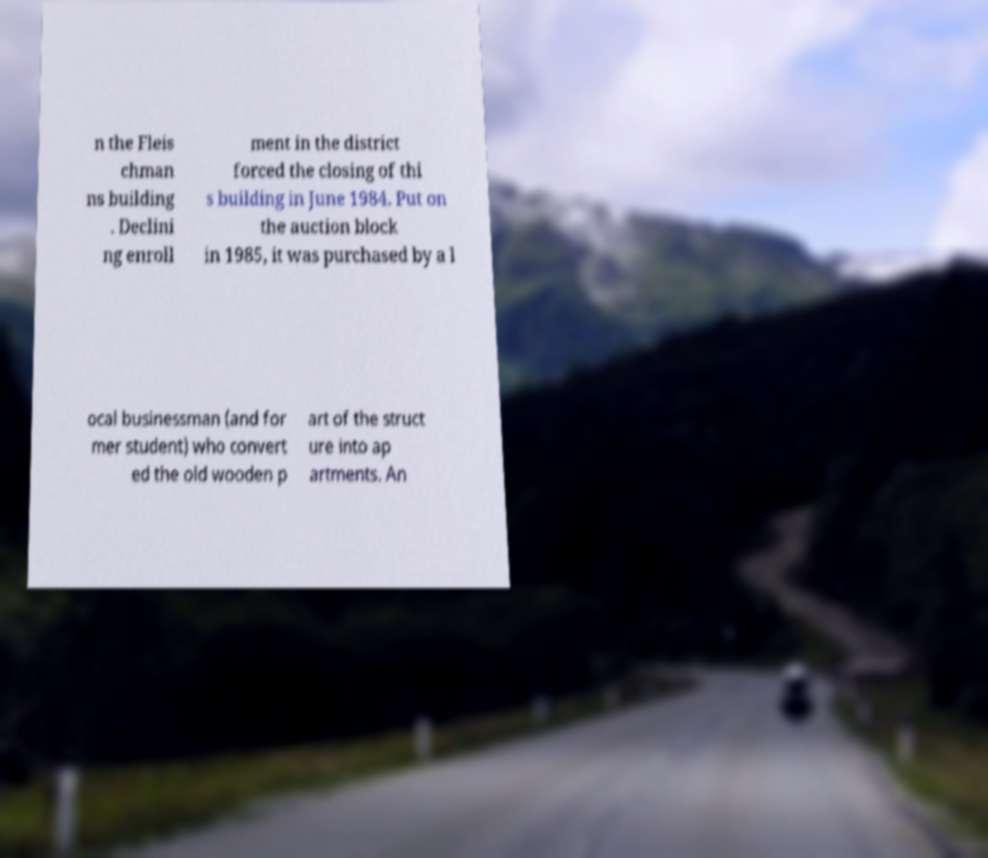What messages or text are displayed in this image? I need them in a readable, typed format. n the Fleis chman ns building . Declini ng enroll ment in the district forced the closing of thi s building in June 1984. Put on the auction block in 1985, it was purchased by a l ocal businessman (and for mer student) who convert ed the old wooden p art of the struct ure into ap artments. An 